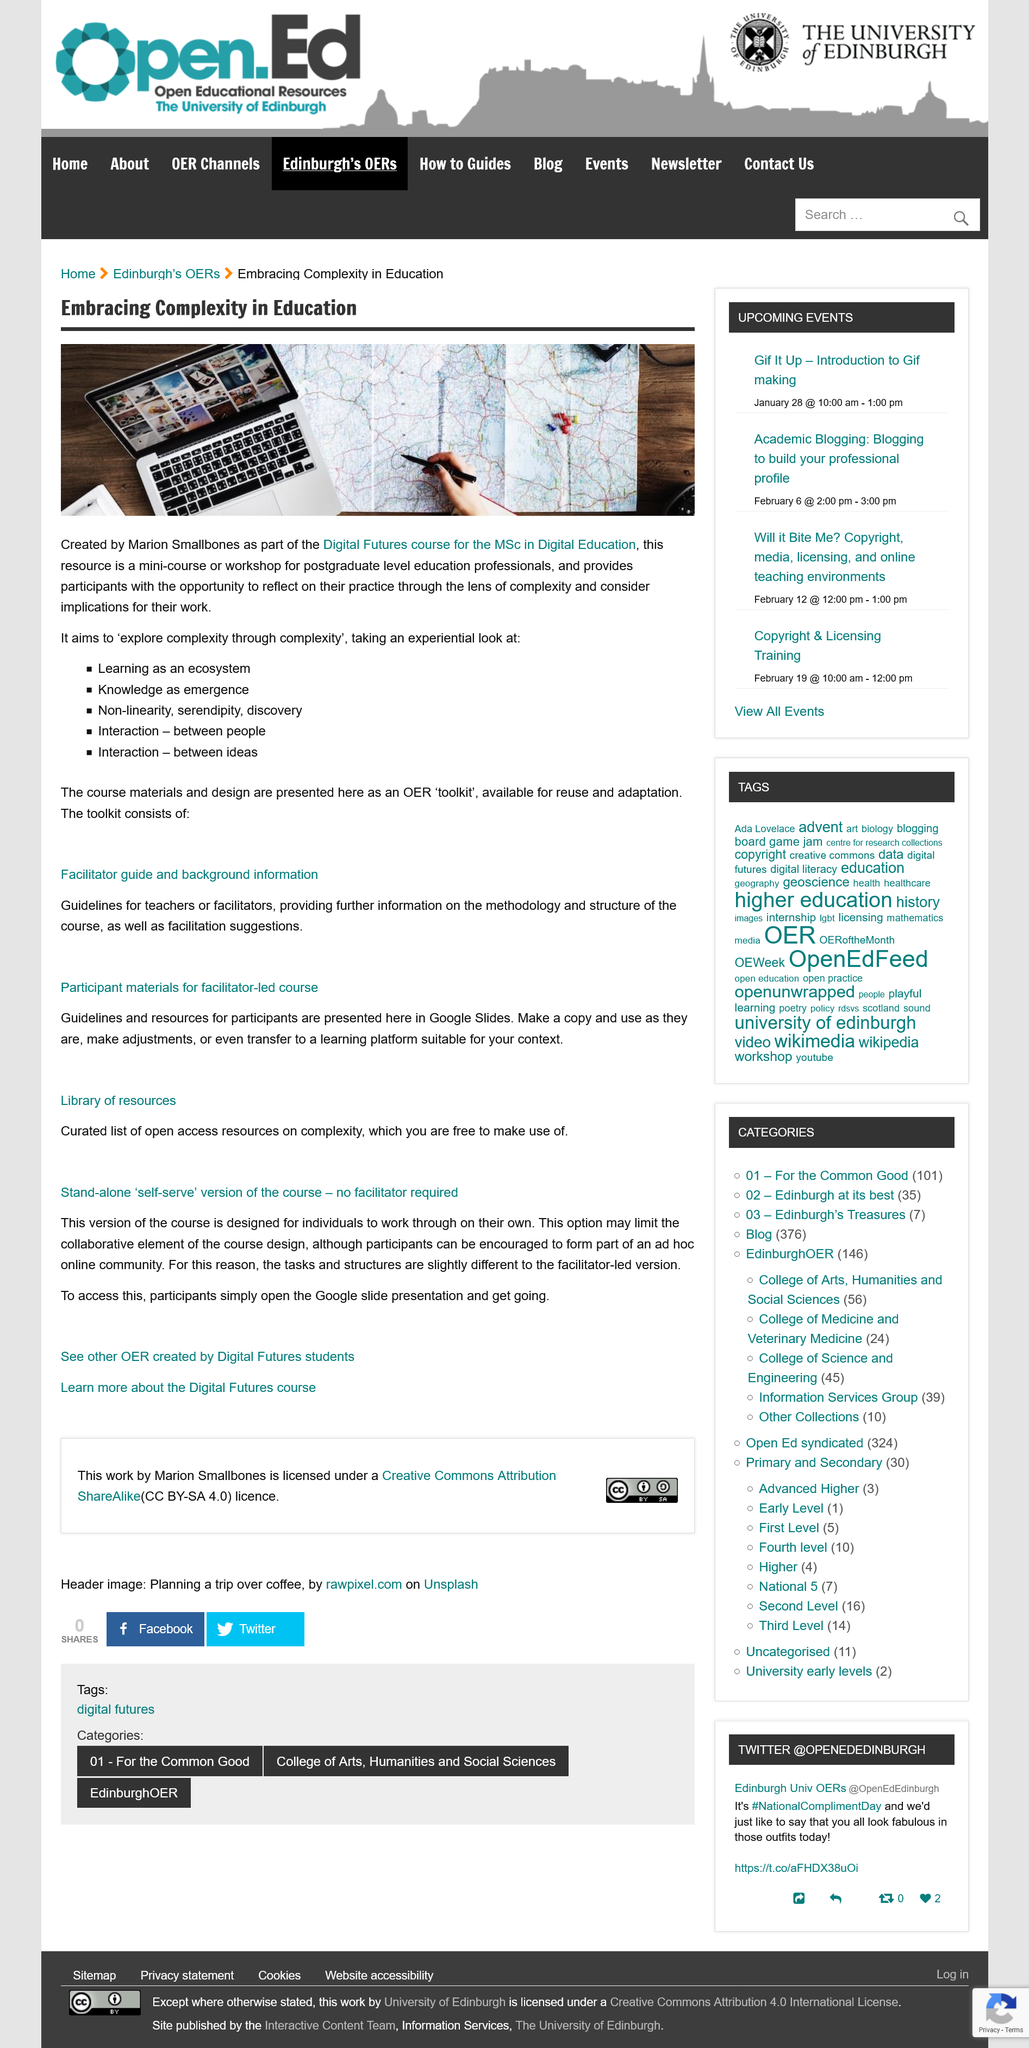Highlight a few significant elements in this photo. The limited version of the course for individuals does not include the collaborative element of the course design, which limits its overall effectiveness. The Facilitator guide provides guidelines for teachers or facilitators, includes information on the methodology and structure of the course, and offers facilitation suggestions. The concept of non-linearity, serendipity, and discovery is being examined experientially, as one of the key elements of the phenomenon being studied. Yes, it is possible to make changes to the resources in Google Slides, or to transfer them to a platform better suited for your needs. Participants can be encouraged to form part of an ad hoc online community that is dedicated to sharing information, resources, and best practices related to a specific topic or project. 